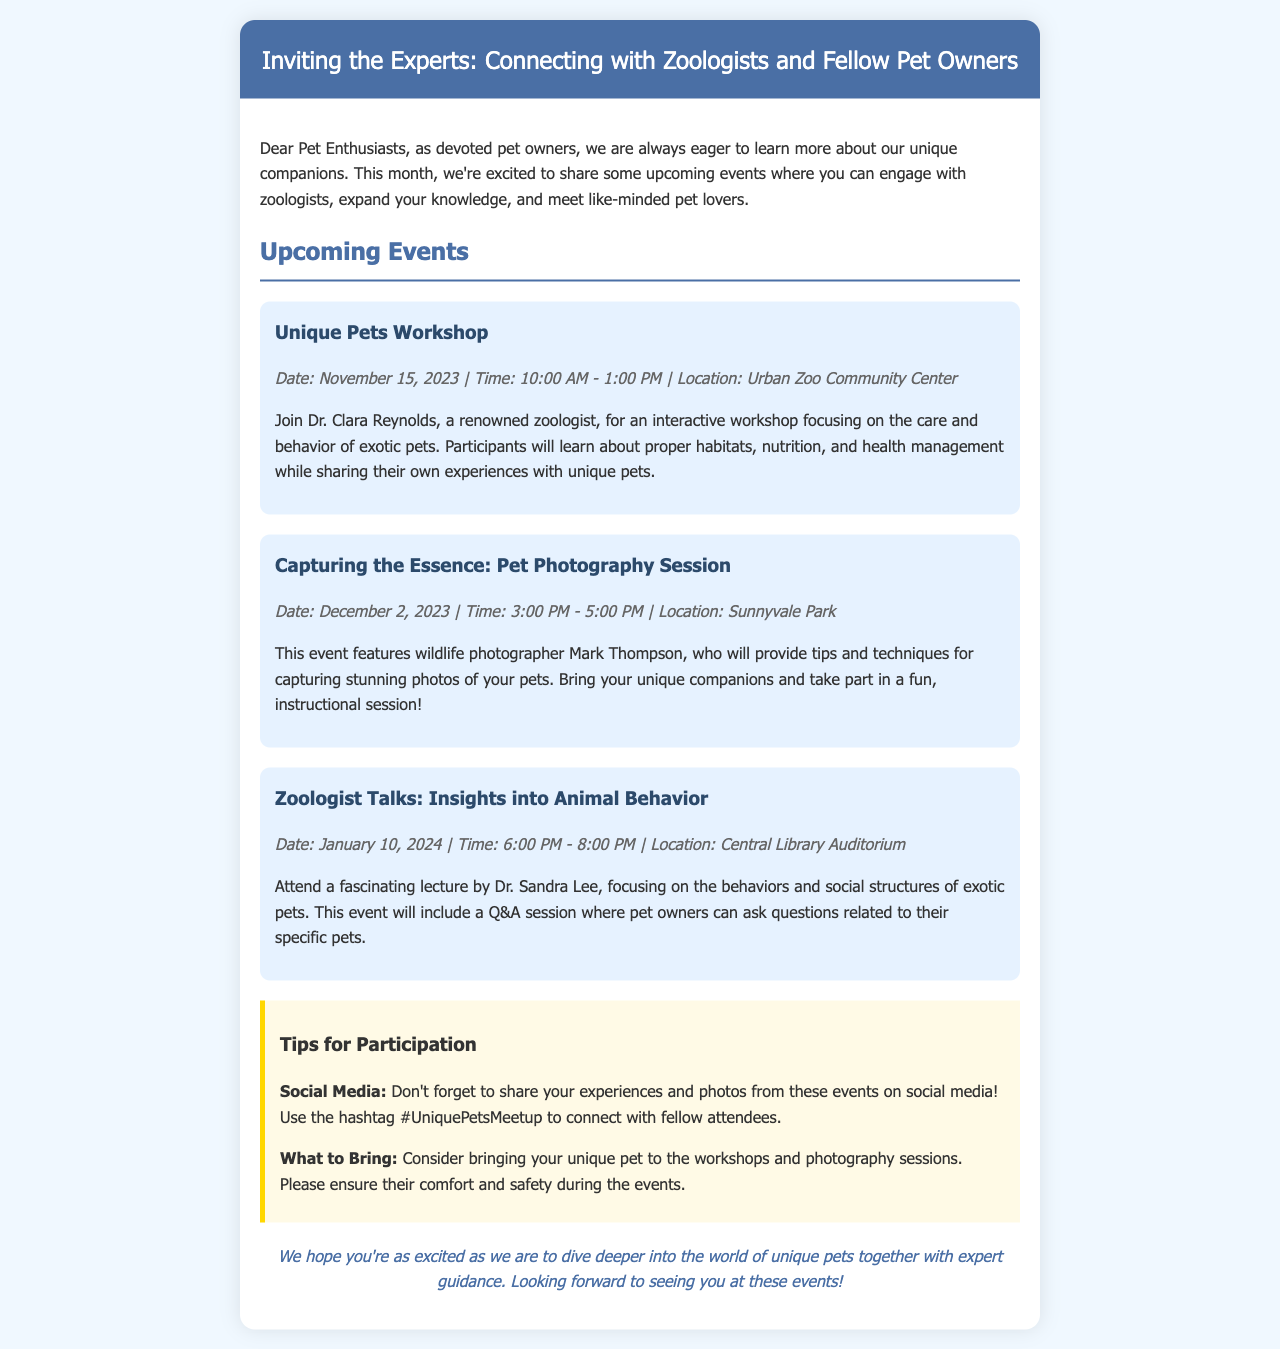What is the title of the newsletter? The title is displayed prominently at the top of the document as the main focus for readers.
Answer: Inviting the Experts: Connecting with Zoologists and Fellow Pet Owners When is the Unique Pets Workshop scheduled? The date is mentioned in the details of the workshop, highlighting when it takes place.
Answer: November 15, 2023 Who is hosting the Capturing the Essence: Pet Photography Session? The name of the wildlife photographer leading the session is provided in the event description.
Answer: Mark Thompson What time does the Zoologist Talks event begin? The start time of the event is specified in the details under the event section.
Answer: 6:00 PM What should participants bring to the workshops and photography sessions? The document advises participants on what to prepare or bring, ensuring their pets' comfort.
Answer: Unique pet What is the purpose of the Unique Pets Workshop? The workshop aims to educate pet owners on important aspects of unique pet care and behavior.
Answer: Care and behavior of exotic pets What hashtag should attendees use on social media? The document encourages sharing experiences and specifies a particular tag to use.
Answer: #UniquePetsMeetup How long is the Capturing the Essence: Pet Photography Session? The duration of the photography session is indicated in the event's time details.
Answer: 2 hours 